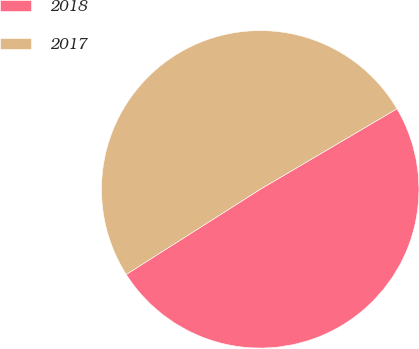<chart> <loc_0><loc_0><loc_500><loc_500><pie_chart><fcel>2018<fcel>2017<nl><fcel>49.46%<fcel>50.54%<nl></chart> 